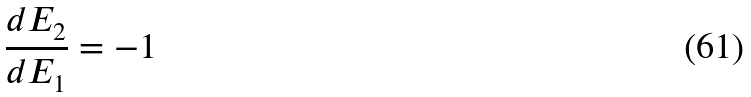<formula> <loc_0><loc_0><loc_500><loc_500>\frac { d E _ { 2 } } { d E _ { 1 } } = - 1</formula> 